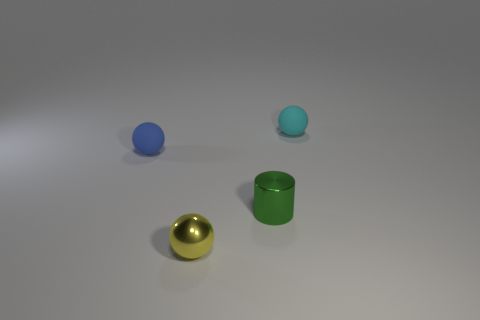How many cyan rubber things have the same shape as the blue matte object?
Your response must be concise. 1. There is a object in front of the green object; what is its material?
Give a very brief answer. Metal. Do the small yellow object on the left side of the green shiny cylinder and the tiny green metal object have the same shape?
Provide a succinct answer. No. Is there another metal cylinder that has the same size as the cylinder?
Offer a terse response. No. Is the shape of the small yellow thing the same as the tiny rubber object that is in front of the cyan thing?
Ensure brevity in your answer.  Yes. Is the number of balls right of the blue thing less than the number of small blue matte balls?
Your response must be concise. No. Is the shape of the small blue matte thing the same as the yellow shiny object?
Make the answer very short. Yes. The other sphere that is made of the same material as the cyan ball is what size?
Provide a short and direct response. Small. Are there fewer metallic cylinders than small brown matte cubes?
Your response must be concise. No. How many tiny objects are either gray rubber spheres or yellow balls?
Provide a succinct answer. 1. 